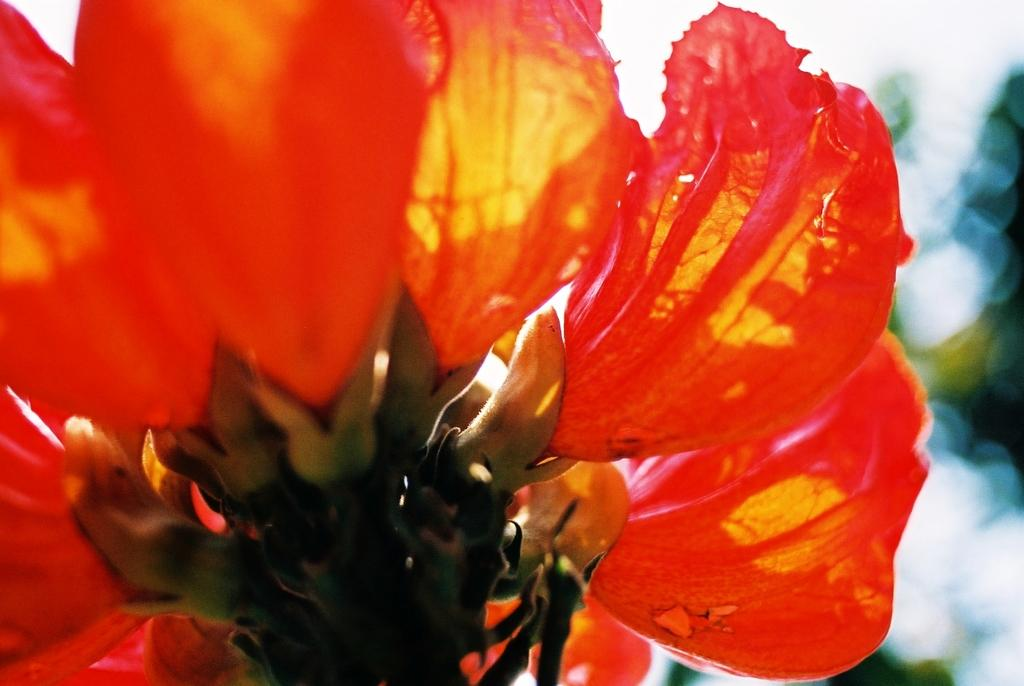What is the main subject of the image? There is a flower in the image. What color is the flower? The flower is red in color. Can you describe the background of the image be described? The background of the image is blurry. How many sisters are present in the image? There are no sisters present in the image, as it only features a red flower with a blurry background. 